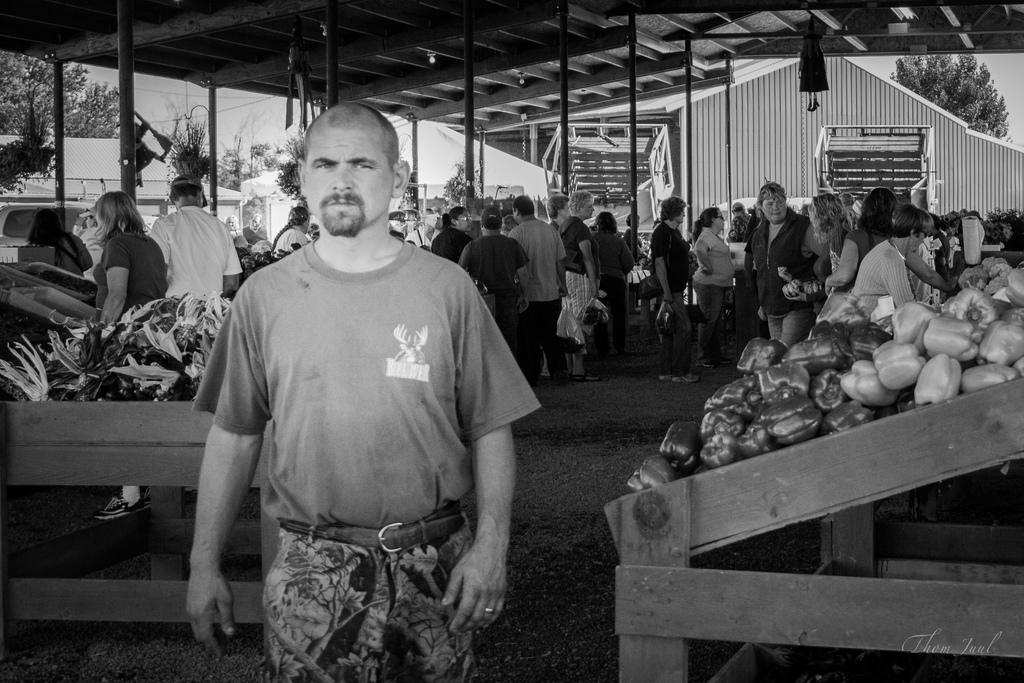What is the color scheme of the image? The image is black and white. What can be seen among the groups of people in the image? There are capsicums and other vegetables in trays in the image. What type of vegetation is visible in the image? There are trees visible in the image. What type of temporary shelter is present in the image? There is a tent in the image. How much glue is needed to attach the cow to the image? There is no cow present in the image, so glue is not needed to attach one. 